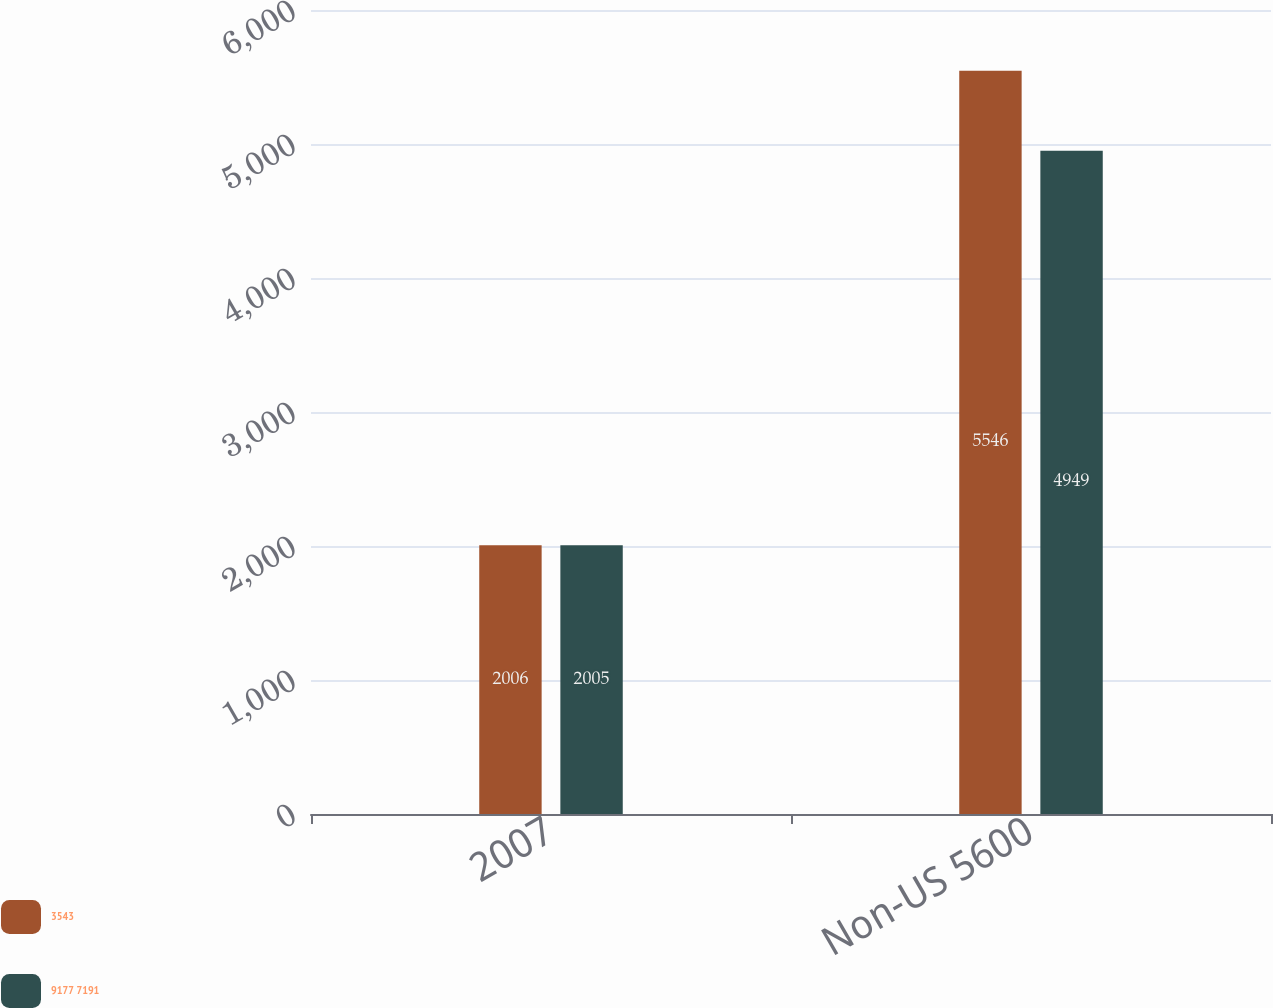Convert chart. <chart><loc_0><loc_0><loc_500><loc_500><stacked_bar_chart><ecel><fcel>2007<fcel>Non-US 5600<nl><fcel>3543<fcel>2006<fcel>5546<nl><fcel>9177 7191<fcel>2005<fcel>4949<nl></chart> 